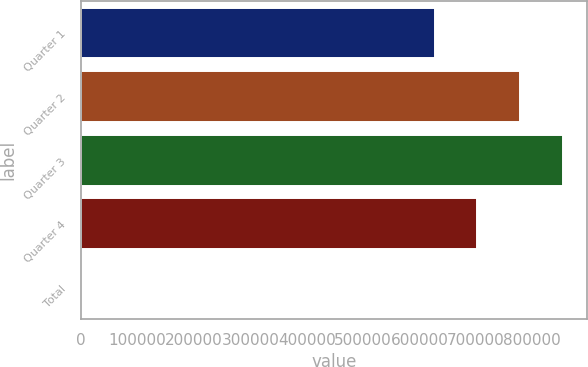Convert chart. <chart><loc_0><loc_0><loc_500><loc_500><bar_chart><fcel>Quarter 1<fcel>Quarter 2<fcel>Quarter 3<fcel>Quarter 4<fcel>Total<nl><fcel>626791<fcel>778113<fcel>853774<fcel>702452<fcel>9.91<nl></chart> 